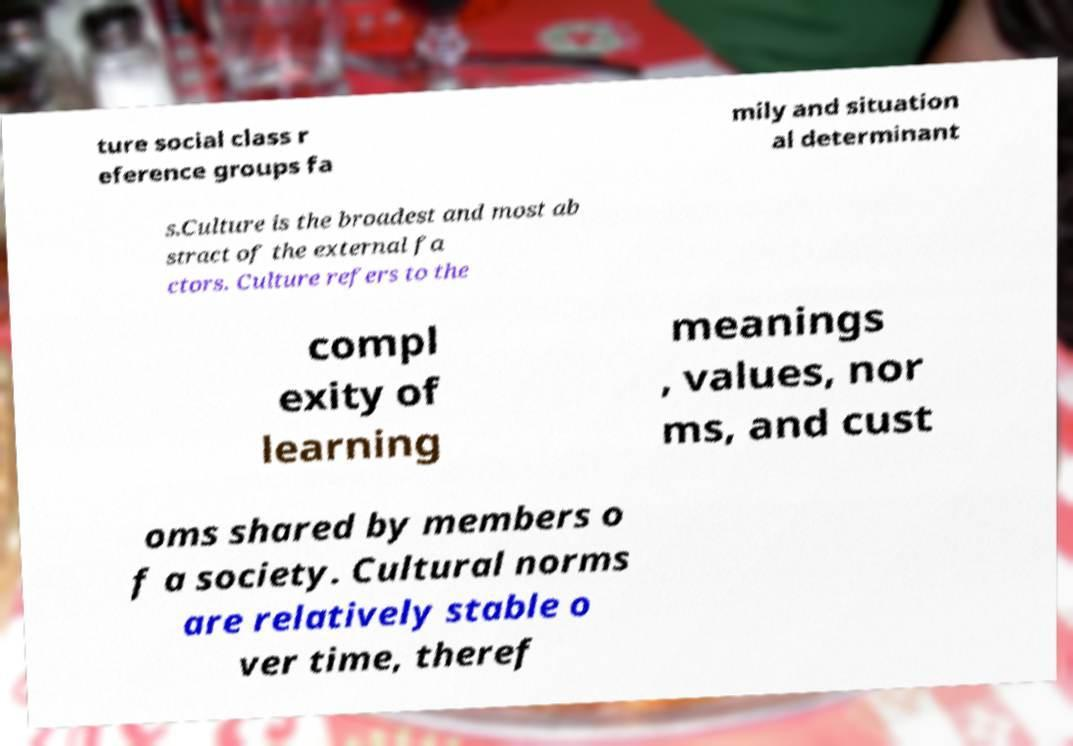Could you assist in decoding the text presented in this image and type it out clearly? ture social class r eference groups fa mily and situation al determinant s.Culture is the broadest and most ab stract of the external fa ctors. Culture refers to the compl exity of learning meanings , values, nor ms, and cust oms shared by members o f a society. Cultural norms are relatively stable o ver time, theref 